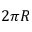Convert formula to latex. <formula><loc_0><loc_0><loc_500><loc_500>2 \pi R</formula> 